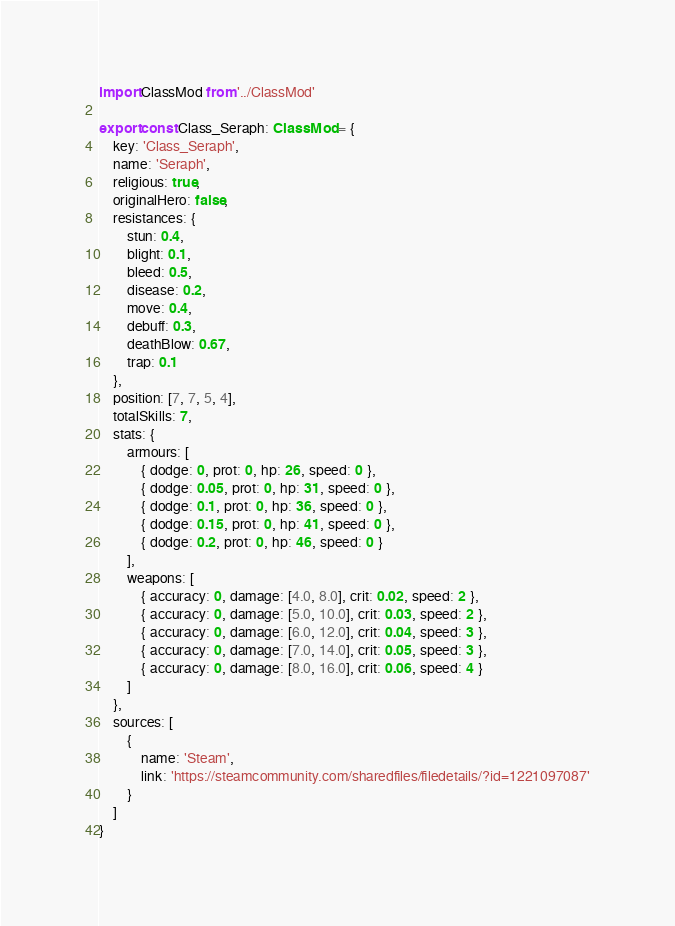Convert code to text. <code><loc_0><loc_0><loc_500><loc_500><_TypeScript_>import ClassMod from '../ClassMod'

export const Class_Seraph: ClassMod = {
    key: 'Class_Seraph',
    name: 'Seraph',
    religious: true,
    originalHero: false,
    resistances: {
        stun: 0.4,
        blight: 0.1,
        bleed: 0.5,
        disease: 0.2,
        move: 0.4,
        debuff: 0.3,
        deathBlow: 0.67,
        trap: 0.1
    },
    position: [7, 7, 5, 4],
    totalSkills: 7,
    stats: {
        armours: [
            { dodge: 0, prot: 0, hp: 26, speed: 0 },
            { dodge: 0.05, prot: 0, hp: 31, speed: 0 },
            { dodge: 0.1, prot: 0, hp: 36, speed: 0 },
            { dodge: 0.15, prot: 0, hp: 41, speed: 0 },
            { dodge: 0.2, prot: 0, hp: 46, speed: 0 }
        ],
        weapons: [
            { accuracy: 0, damage: [4.0, 8.0], crit: 0.02, speed: 2 },
            { accuracy: 0, damage: [5.0, 10.0], crit: 0.03, speed: 2 },
            { accuracy: 0, damage: [6.0, 12.0], crit: 0.04, speed: 3 },
            { accuracy: 0, damage: [7.0, 14.0], crit: 0.05, speed: 3 },
            { accuracy: 0, damage: [8.0, 16.0], crit: 0.06, speed: 4 }
        ]
    },
    sources: [
        {
            name: 'Steam',
            link: 'https://steamcommunity.com/sharedfiles/filedetails/?id=1221097087'
        }
    ]
}
</code> 